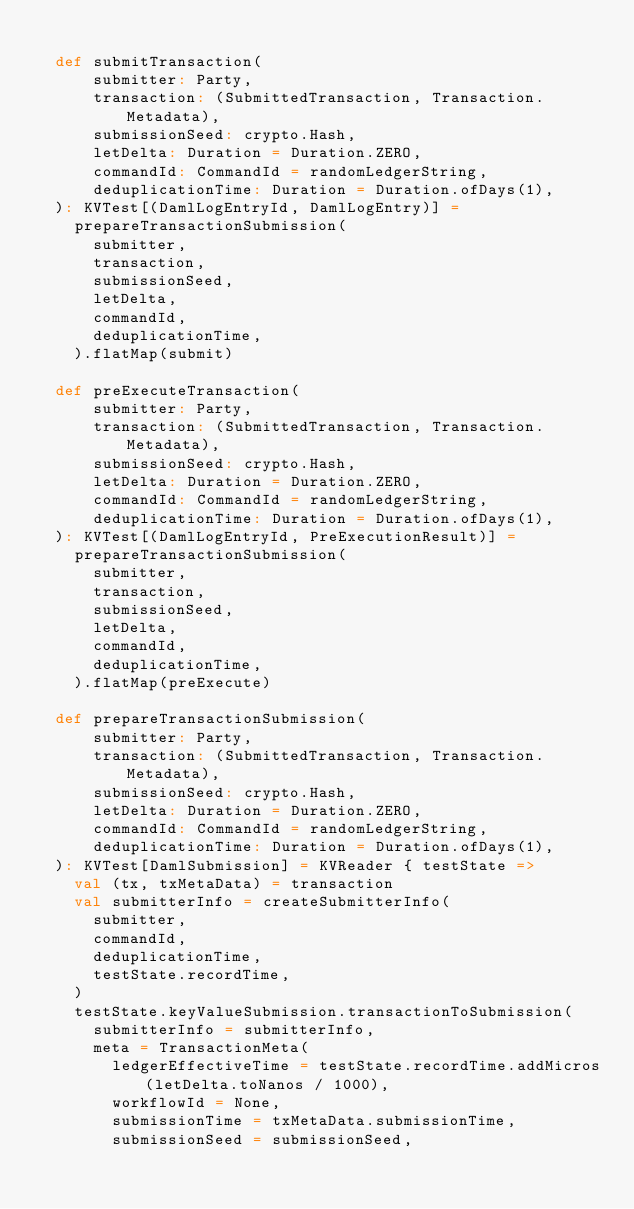<code> <loc_0><loc_0><loc_500><loc_500><_Scala_>
  def submitTransaction(
      submitter: Party,
      transaction: (SubmittedTransaction, Transaction.Metadata),
      submissionSeed: crypto.Hash,
      letDelta: Duration = Duration.ZERO,
      commandId: CommandId = randomLedgerString,
      deduplicationTime: Duration = Duration.ofDays(1),
  ): KVTest[(DamlLogEntryId, DamlLogEntry)] =
    prepareTransactionSubmission(
      submitter,
      transaction,
      submissionSeed,
      letDelta,
      commandId,
      deduplicationTime,
    ).flatMap(submit)

  def preExecuteTransaction(
      submitter: Party,
      transaction: (SubmittedTransaction, Transaction.Metadata),
      submissionSeed: crypto.Hash,
      letDelta: Duration = Duration.ZERO,
      commandId: CommandId = randomLedgerString,
      deduplicationTime: Duration = Duration.ofDays(1),
  ): KVTest[(DamlLogEntryId, PreExecutionResult)] =
    prepareTransactionSubmission(
      submitter,
      transaction,
      submissionSeed,
      letDelta,
      commandId,
      deduplicationTime,
    ).flatMap(preExecute)

  def prepareTransactionSubmission(
      submitter: Party,
      transaction: (SubmittedTransaction, Transaction.Metadata),
      submissionSeed: crypto.Hash,
      letDelta: Duration = Duration.ZERO,
      commandId: CommandId = randomLedgerString,
      deduplicationTime: Duration = Duration.ofDays(1),
  ): KVTest[DamlSubmission] = KVReader { testState =>
    val (tx, txMetaData) = transaction
    val submitterInfo = createSubmitterInfo(
      submitter,
      commandId,
      deduplicationTime,
      testState.recordTime,
    )
    testState.keyValueSubmission.transactionToSubmission(
      submitterInfo = submitterInfo,
      meta = TransactionMeta(
        ledgerEffectiveTime = testState.recordTime.addMicros(letDelta.toNanos / 1000),
        workflowId = None,
        submissionTime = txMetaData.submissionTime,
        submissionSeed = submissionSeed,</code> 